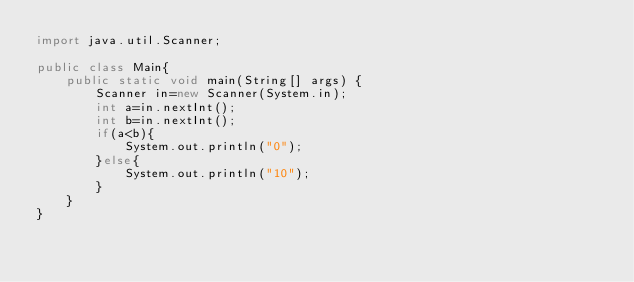Convert code to text. <code><loc_0><loc_0><loc_500><loc_500><_Java_>import java.util.Scanner;

public class Main{
    public static void main(String[] args) {
        Scanner in=new Scanner(System.in);
        int a=in.nextInt();
        int b=in.nextInt();
        if(a<b){
            System.out.println("0");
        }else{
            System.out.println("10");
        }
    }
}</code> 